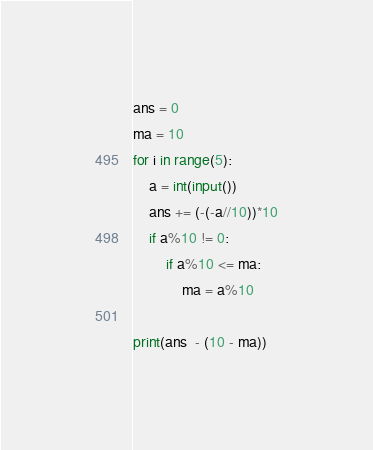Convert code to text. <code><loc_0><loc_0><loc_500><loc_500><_Python_>ans = 0
ma = 10
for i in range(5):
    a = int(input())
    ans += (-(-a//10))*10
    if a%10 != 0:
        if a%10 <= ma:
            ma = a%10

print(ans  - (10 - ma))</code> 